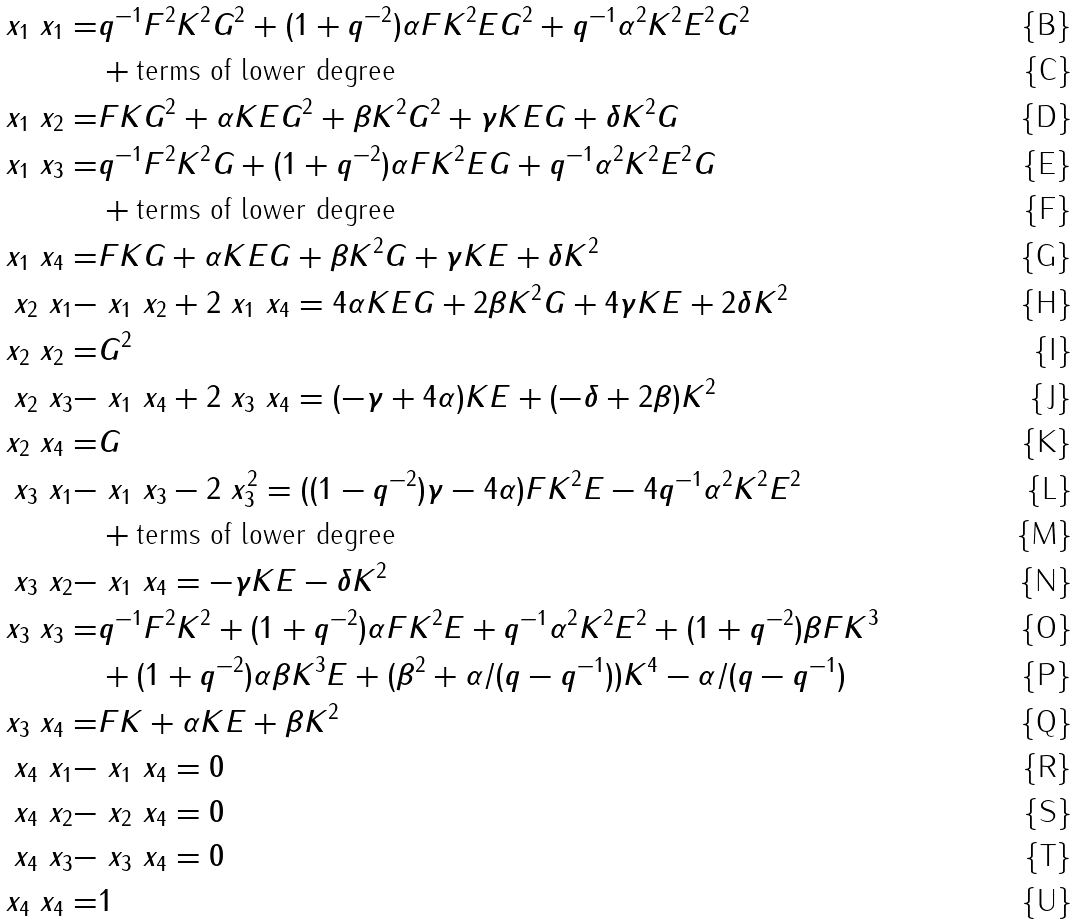<formula> <loc_0><loc_0><loc_500><loc_500>\ x _ { 1 } \ x _ { 1 } = & q ^ { - 1 } F ^ { 2 } K ^ { 2 } G ^ { 2 } + ( 1 + q ^ { - 2 } ) \alpha F K ^ { 2 } E G ^ { 2 } + q ^ { - 1 } \alpha ^ { 2 } K ^ { 2 } E ^ { 2 } G ^ { 2 } \\ & + \text {terms of lower degree} \\ \ x _ { 1 } \ x _ { 2 } = & F K G ^ { 2 } + \alpha K E G ^ { 2 } + \beta K ^ { 2 } G ^ { 2 } + \gamma K E G + \delta K ^ { 2 } G \\ \ x _ { 1 } \ x _ { 3 } = & q ^ { - 1 } F ^ { 2 } K ^ { 2 } G + ( 1 + q ^ { - 2 } ) \alpha F K ^ { 2 } E G + q ^ { - 1 } \alpha ^ { 2 } K ^ { 2 } E ^ { 2 } G \\ & + \text {terms of lower degree} \\ \ x _ { 1 } \ x _ { 4 } = & F K G + \alpha K E G + \beta K ^ { 2 } G + \gamma K E + \delta K ^ { 2 } \\ \ x _ { 2 } \ x _ { 1 } - & \ x _ { 1 } \ x _ { 2 } + 2 \ x _ { 1 } \ x _ { 4 } = 4 \alpha K E G + 2 \beta K ^ { 2 } G + 4 \gamma K E + 2 \delta K ^ { 2 } \\ \ x _ { 2 } \ x _ { 2 } = & G ^ { 2 } \\ \ x _ { 2 } \ x _ { 3 } - & \ x _ { 1 } \ x _ { 4 } + 2 \ x _ { 3 } \ x _ { 4 } = ( - \gamma + 4 \alpha ) K E + ( - \delta + 2 \beta ) K ^ { 2 } \\ \ x _ { 2 } \ x _ { 4 } = & G \\ \ x _ { 3 } \ x _ { 1 } - & \ x _ { 1 } \ x _ { 3 } - 2 \ x _ { 3 } ^ { 2 } = ( ( 1 - q ^ { - 2 } ) \gamma - 4 \alpha ) F K ^ { 2 } E - 4 q ^ { - 1 } \alpha ^ { 2 } K ^ { 2 } E ^ { 2 } \\ & + \text {terms of lower degree} \\ \ x _ { 3 } \ x _ { 2 } - & \ x _ { 1 } \ x _ { 4 } = - \gamma K E - \delta K ^ { 2 } \\ \ x _ { 3 } \ x _ { 3 } = & q ^ { - 1 } F ^ { 2 } K ^ { 2 } + ( 1 + q ^ { - 2 } ) \alpha F K ^ { 2 } E + q ^ { - 1 } \alpha ^ { 2 } K ^ { 2 } E ^ { 2 } + ( 1 + q ^ { - 2 } ) \beta F K ^ { 3 } \\ & + ( 1 + q ^ { - 2 } ) \alpha \beta K ^ { 3 } E + ( \beta ^ { 2 } + \alpha / ( q - q ^ { - 1 } ) ) K ^ { 4 } - \alpha / ( q - q ^ { - 1 } ) \\ \ x _ { 3 } \ x _ { 4 } = & F K + \alpha K E + \beta K ^ { 2 } \\ \ x _ { 4 } \ x _ { 1 } - & \ x _ { 1 } \ x _ { 4 } = 0 \\ \ x _ { 4 } \ x _ { 2 } - & \ x _ { 2 } \ x _ { 4 } = 0 \\ \ x _ { 4 } \ x _ { 3 } - & \ x _ { 3 } \ x _ { 4 } = 0 \\ \ x _ { 4 } \ x _ { 4 } = & 1</formula> 